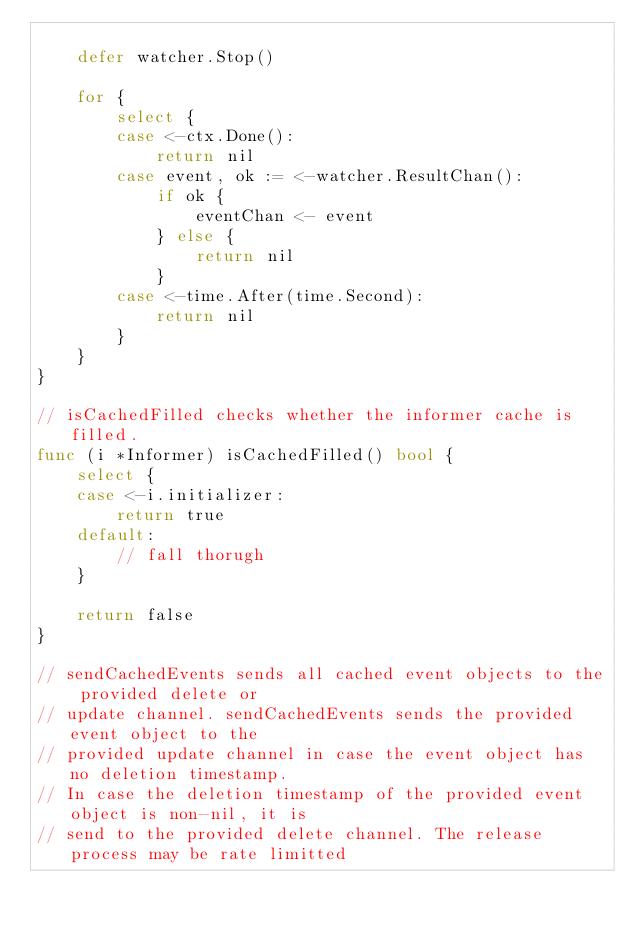<code> <loc_0><loc_0><loc_500><loc_500><_Go_>
	defer watcher.Stop()

	for {
		select {
		case <-ctx.Done():
			return nil
		case event, ok := <-watcher.ResultChan():
			if ok {
				eventChan <- event
			} else {
				return nil
			}
		case <-time.After(time.Second):
			return nil
		}
	}
}

// isCachedFilled checks whether the informer cache is filled.
func (i *Informer) isCachedFilled() bool {
	select {
	case <-i.initializer:
		return true
	default:
		// fall thorugh
	}

	return false
}

// sendCachedEvents sends all cached event objects to the provided delete or
// update channel. sendCachedEvents sends the provided event object to the
// provided update channel in case the event object has no deletion timestamp.
// In case the deletion timestamp of the provided event object is non-nil, it is
// send to the provided delete channel. The release process may be rate limitted</code> 